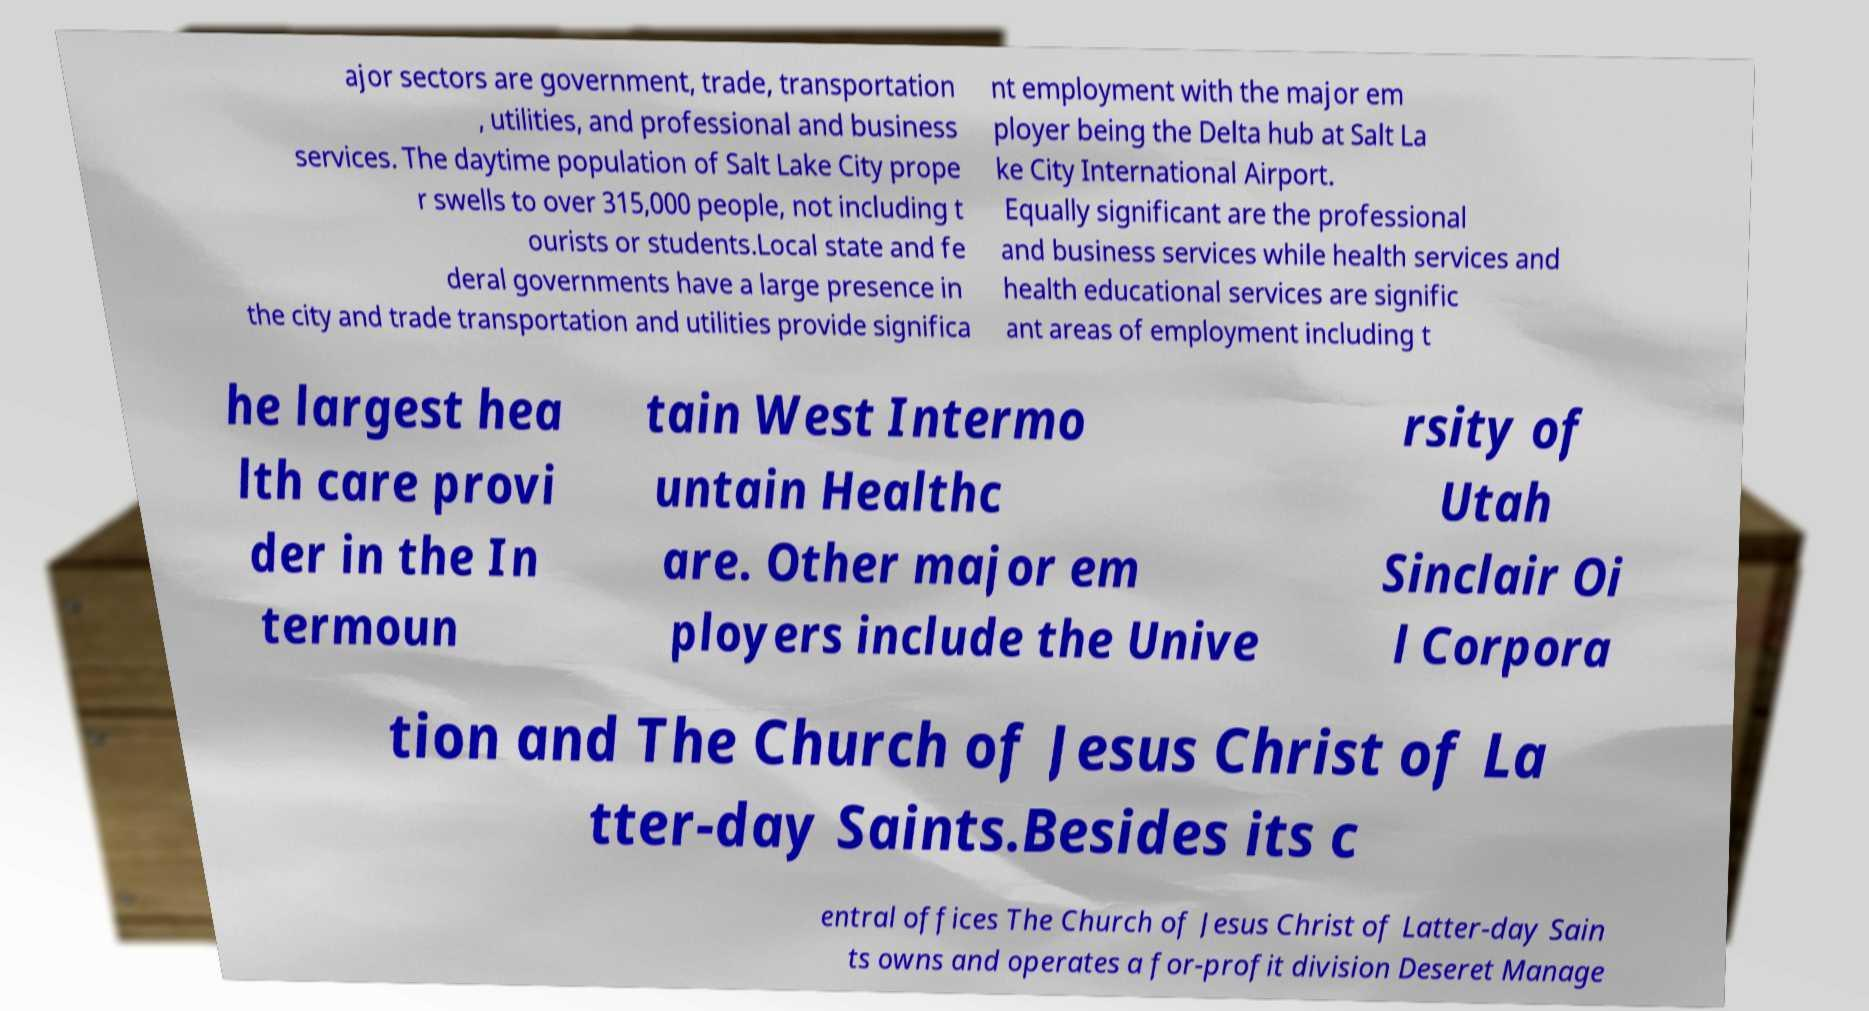What messages or text are displayed in this image? I need them in a readable, typed format. ajor sectors are government, trade, transportation , utilities, and professional and business services. The daytime population of Salt Lake City prope r swells to over 315,000 people, not including t ourists or students.Local state and fe deral governments have a large presence in the city and trade transportation and utilities provide significa nt employment with the major em ployer being the Delta hub at Salt La ke City International Airport. Equally significant are the professional and business services while health services and health educational services are signific ant areas of employment including t he largest hea lth care provi der in the In termoun tain West Intermo untain Healthc are. Other major em ployers include the Unive rsity of Utah Sinclair Oi l Corpora tion and The Church of Jesus Christ of La tter-day Saints.Besides its c entral offices The Church of Jesus Christ of Latter-day Sain ts owns and operates a for-profit division Deseret Manage 